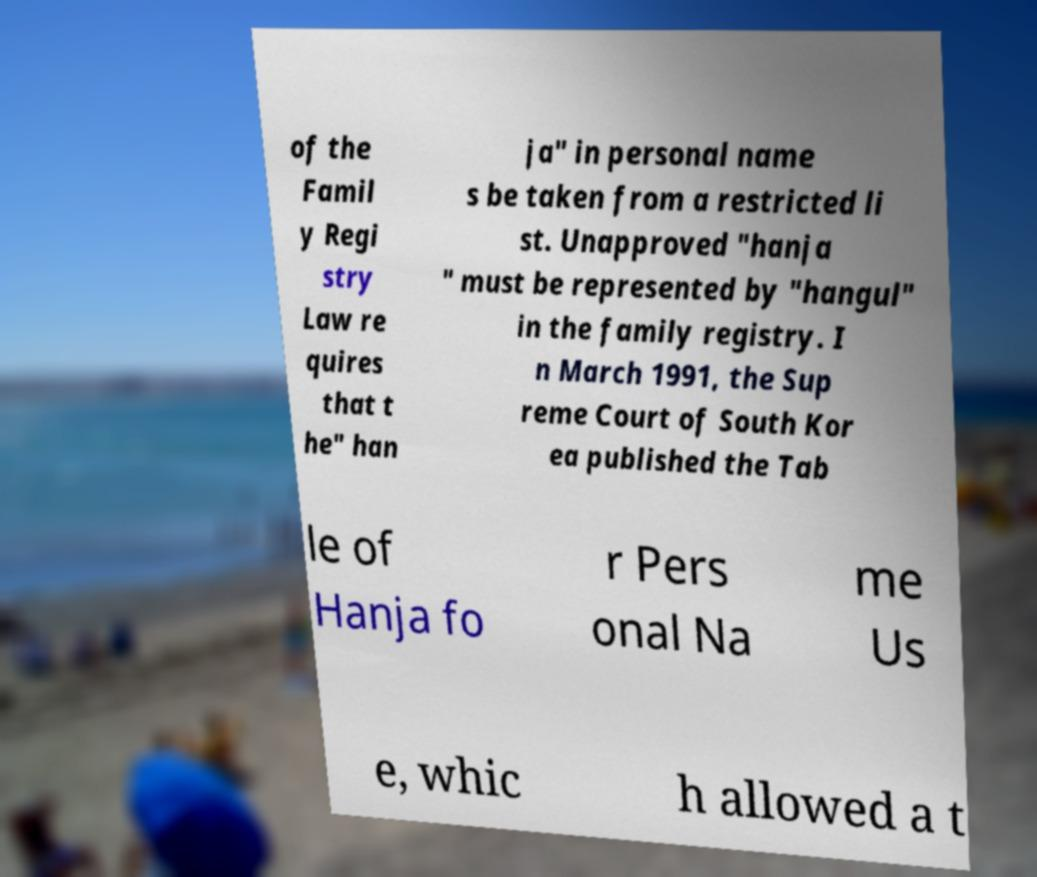There's text embedded in this image that I need extracted. Can you transcribe it verbatim? of the Famil y Regi stry Law re quires that t he" han ja" in personal name s be taken from a restricted li st. Unapproved "hanja " must be represented by "hangul" in the family registry. I n March 1991, the Sup reme Court of South Kor ea published the Tab le of Hanja fo r Pers onal Na me Us e, whic h allowed a t 